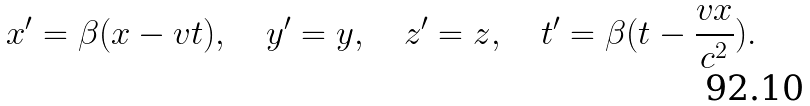<formula> <loc_0><loc_0><loc_500><loc_500>x ^ { \prime } = \beta ( x - v t ) , \quad y ^ { \prime } = y , \quad z ^ { \prime } = z , \quad t ^ { \prime } = \beta ( t - \frac { v x } { c ^ { 2 } } ) .</formula> 